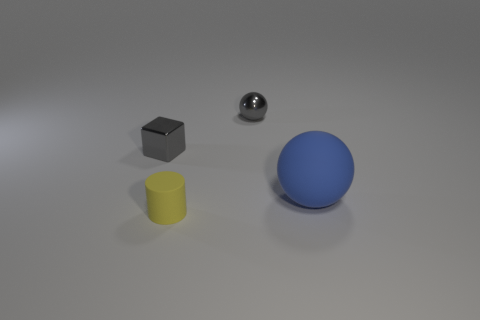There is a tiny gray metallic thing that is in front of the thing that is behind the gray metal block; how many blue things are behind it?
Your answer should be very brief. 0. The cylinder that is the same size as the gray shiny cube is what color?
Provide a succinct answer. Yellow. What is the size of the gray shiny object to the left of the rubber object in front of the blue object?
Provide a succinct answer. Small. What size is the shiny ball that is the same color as the tiny cube?
Offer a very short reply. Small. What number of other things are the same size as the yellow object?
Your answer should be very brief. 2. What number of blue things are there?
Offer a terse response. 1. Is the blue sphere the same size as the rubber cylinder?
Ensure brevity in your answer.  No. What number of other things are there of the same shape as the blue rubber thing?
Keep it short and to the point. 1. There is a object to the left of the tiny thing that is in front of the large ball; what is its material?
Keep it short and to the point. Metal. Are there any tiny things left of the tiny yellow rubber cylinder?
Provide a succinct answer. Yes. 